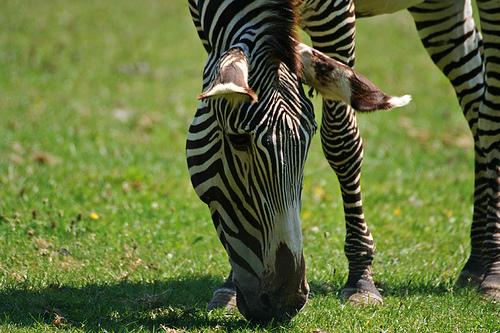What is the animal smelling?
Be succinct. Grass. How many hooves are visible?
Be succinct. 4. Is it sunny outside?
Give a very brief answer. Yes. 